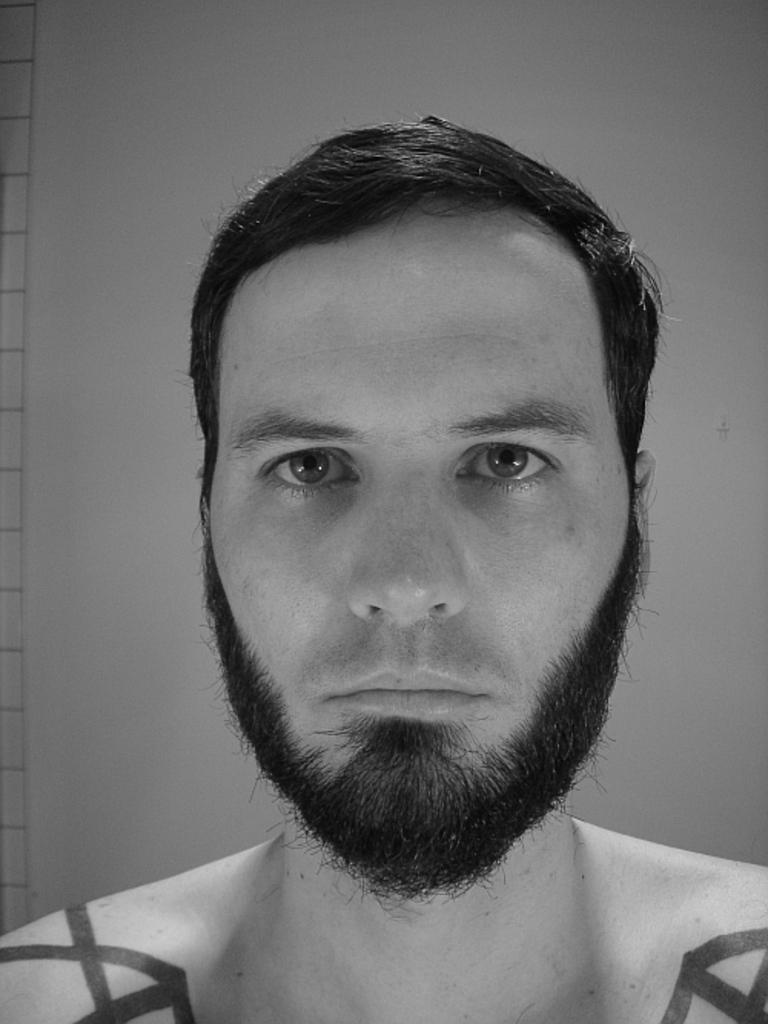Can you describe this image briefly? This is a black and white image. Here I can see a man looking at the picture and I can see few paintings on his shoulders. In the background there is a wall. 